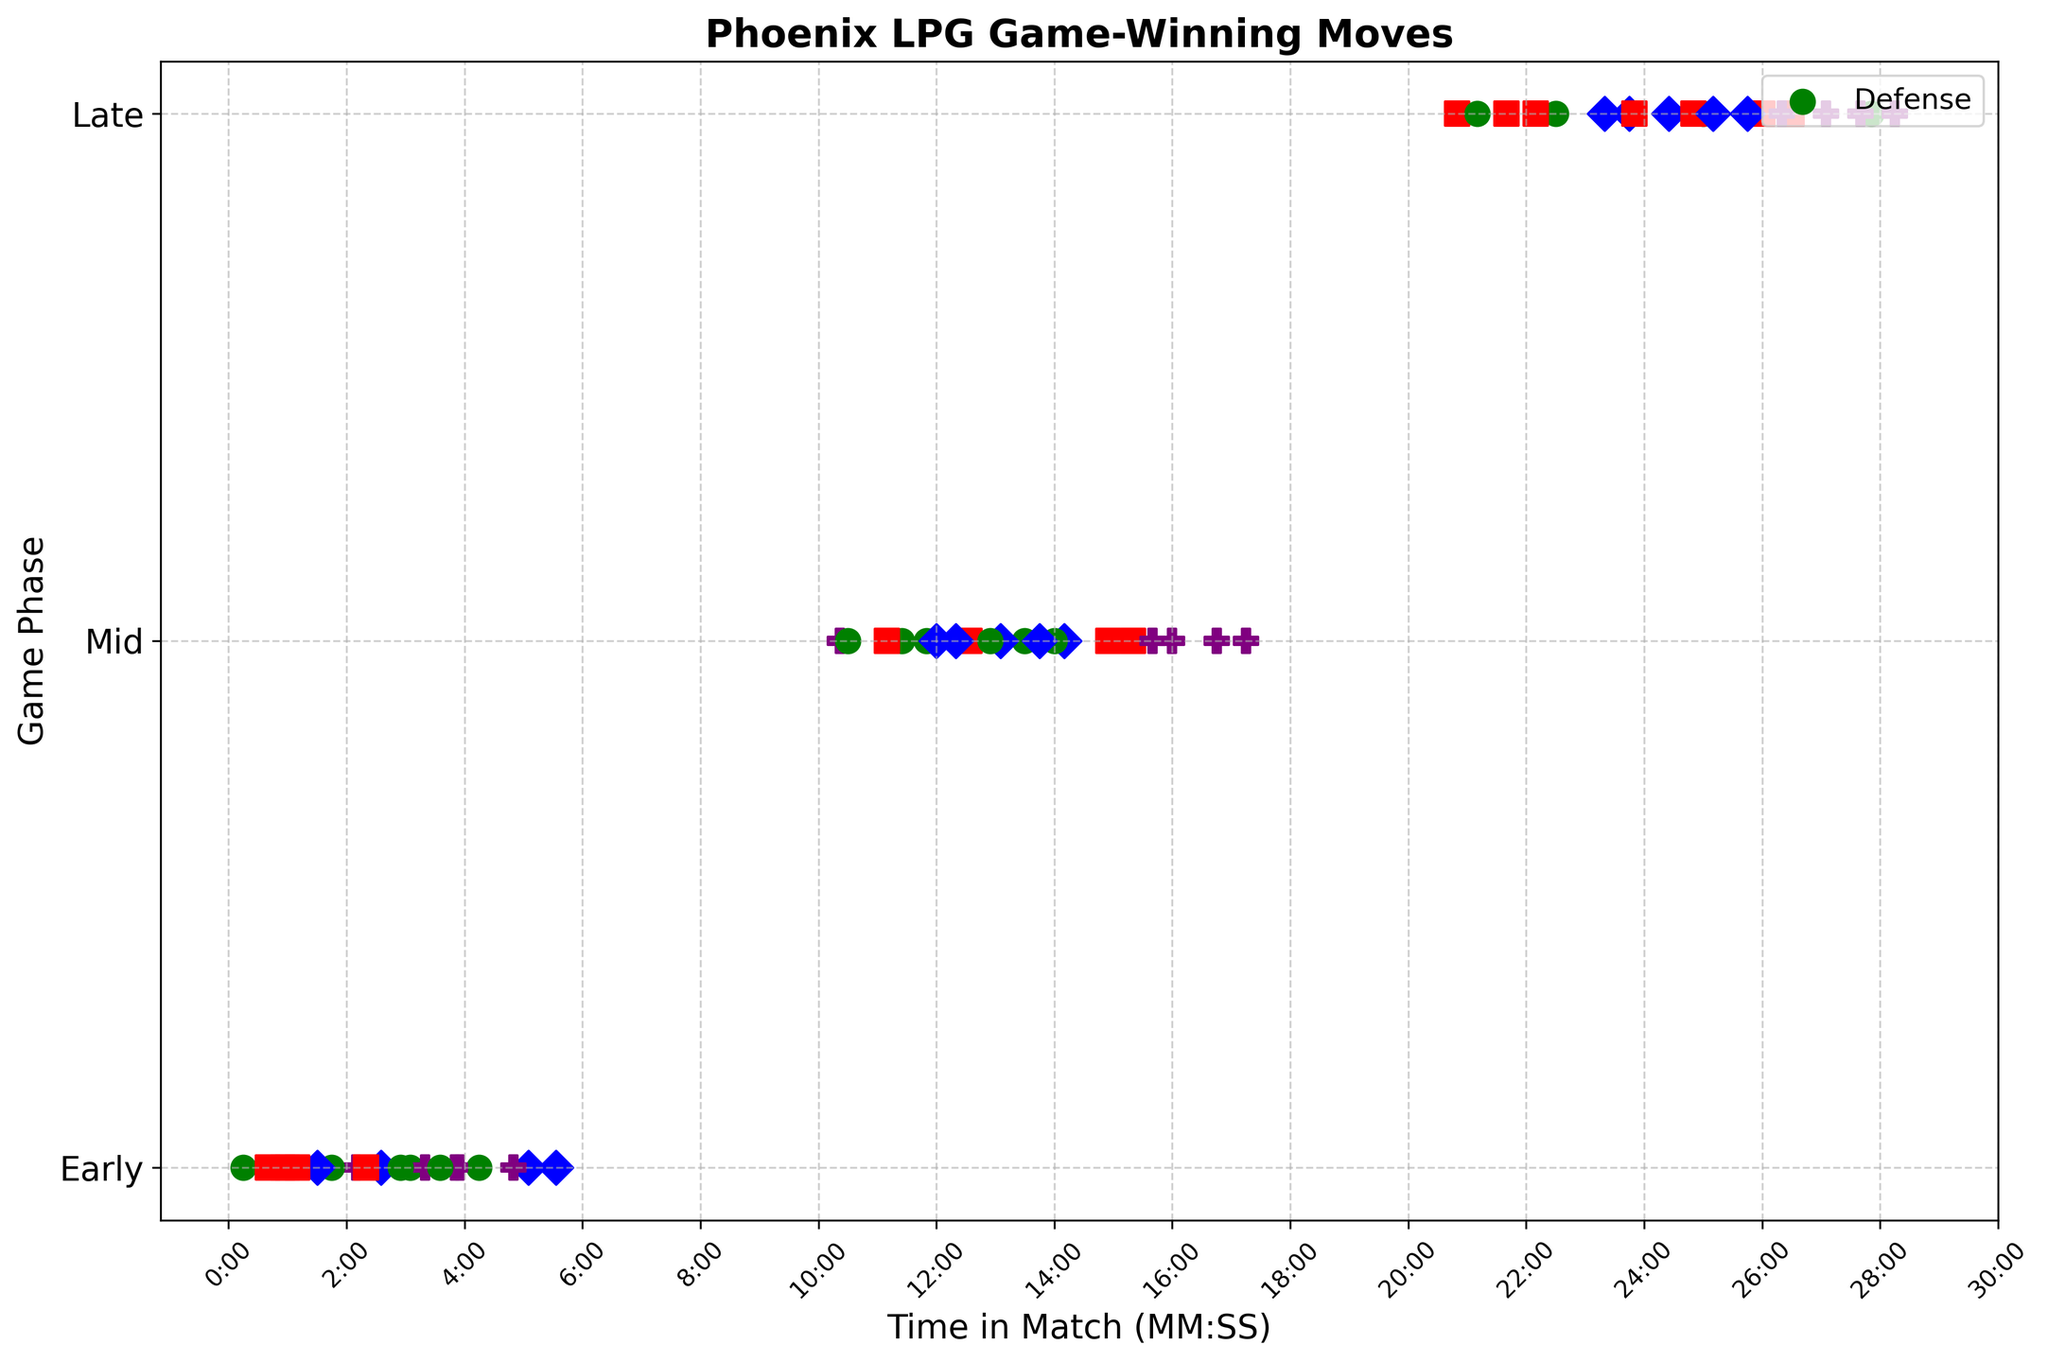What is the most common move type during the early game phase? To find the most common move type in the early game phase, look at the data points in the "Early" row. Count the frequency of each color: green (Defense), red (Attack), blue (Special), and purple (Strategy). Identify which color appears most frequently.
Answer: Defense How many game-winning moves were made using the "Attack" move type in the mid game phase? Locate the data points in the "Mid" row and count the number of red (Attack) points. Each red point represents a game-winning move of type "Attack".
Answer: 5 Which game phase has the highest number of "Special" move types? Look for the blue (Special) data points in each of the three game phases: Early, Mid, and Late. Count the number of blue points in each phase and identify which phase has the highest count.
Answer: Mid What is the time range for game-winning moves in the late game phase? Identify all the data points in the "Late" row. For these points, read their positions along the time axis and find the minimum and maximum times displayed. Convert the times into a human-readable format (MM:SS).
Answer: 20:50 - 28:15 How does the number of strategic moves compare between the early and late game phases? Count the purple (Strategy) data points in both the early and late rows. Compare the counts to find which phase has more strategic moves.
Answer: Equal What is the average time of game-winning moves in the mid game phase? Identify all data points in the "Mid" row. Convert their time positions to seconds, sum these values, and divide by the total number of data points in this row.
Answer: 13:16 Which move type is most evenly distributed across game phases? Compare the number of data points of each color (move type) across the game phases. Determine which color appears relatively equally across Early, Mid, and Late rows.
Answer: Defense During which game phase were the most game-winning moves made? Count the total number of data points in each game phase. Compare the counts for Early, Mid, and Late rows to determine the phase with the highest number of points.
Answer: Mid What percentage of game-winning moves in the early phase are of type "Special"? Count the blue (Special) data points in the "Early" row. Divide this count by the total number of points in the Early row and multiply by 100 to find the percentage.
Answer: 30% 